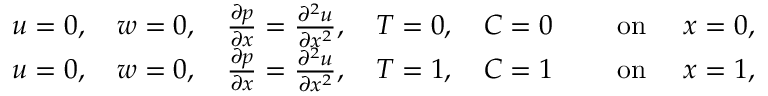Convert formula to latex. <formula><loc_0><loc_0><loc_500><loc_500>\begin{array} { r l } { u = 0 , \quad w = 0 , \quad \frac { \partial p } { \partial x } = \frac { \partial ^ { 2 } u } { \partial x ^ { 2 } } , \quad T = 0 , \quad C = 0 } & { \quad o n \quad x = 0 , } \\ { u = 0 , \quad w = 0 , \quad \frac { \partial p } { \partial x } = \frac { \partial ^ { 2 } u } { \partial x ^ { 2 } } , \quad T = 1 , \quad C = 1 } & { \quad o n \quad x = 1 , } \end{array}</formula> 